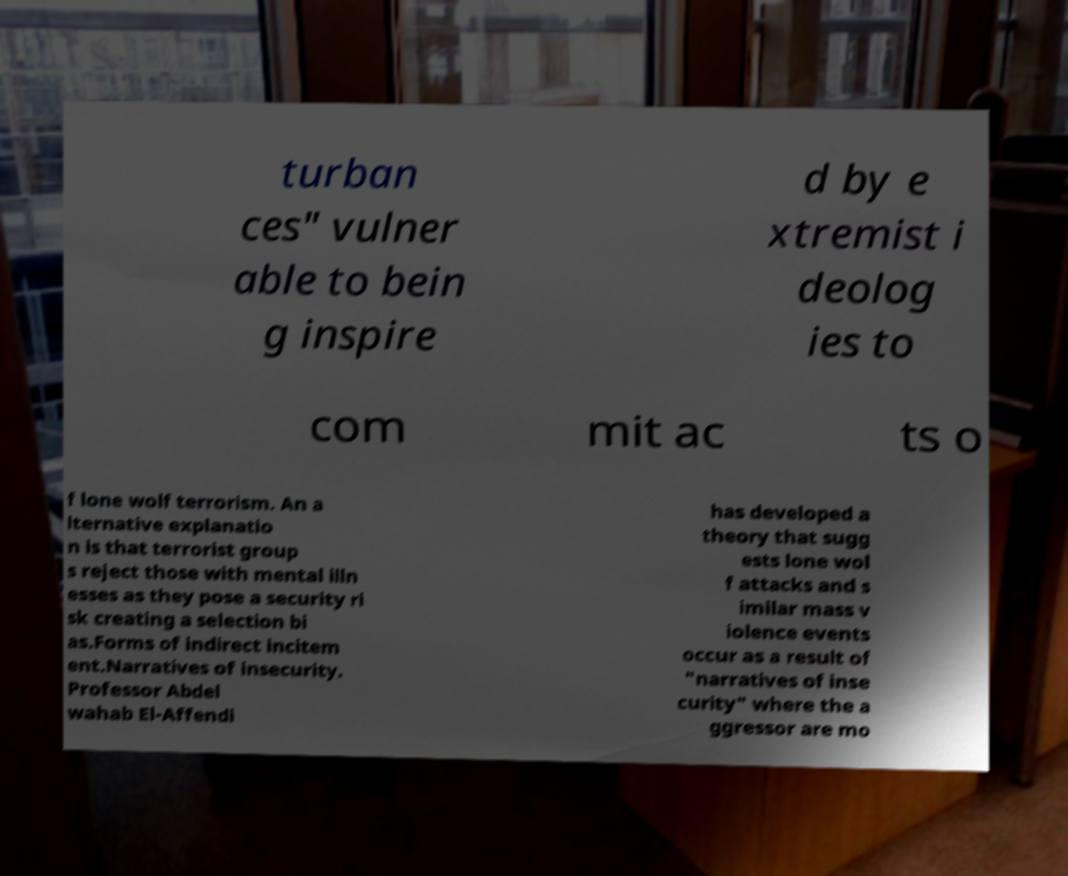Please identify and transcribe the text found in this image. turban ces" vulner able to bein g inspire d by e xtremist i deolog ies to com mit ac ts o f lone wolf terrorism. An a lternative explanatio n is that terrorist group s reject those with mental illn esses as they pose a security ri sk creating a selection bi as.Forms of indirect incitem ent.Narratives of insecurity. Professor Abdel wahab El-Affendi has developed a theory that sugg ests lone wol f attacks and s imilar mass v iolence events occur as a result of "narratives of inse curity" where the a ggressor are mo 